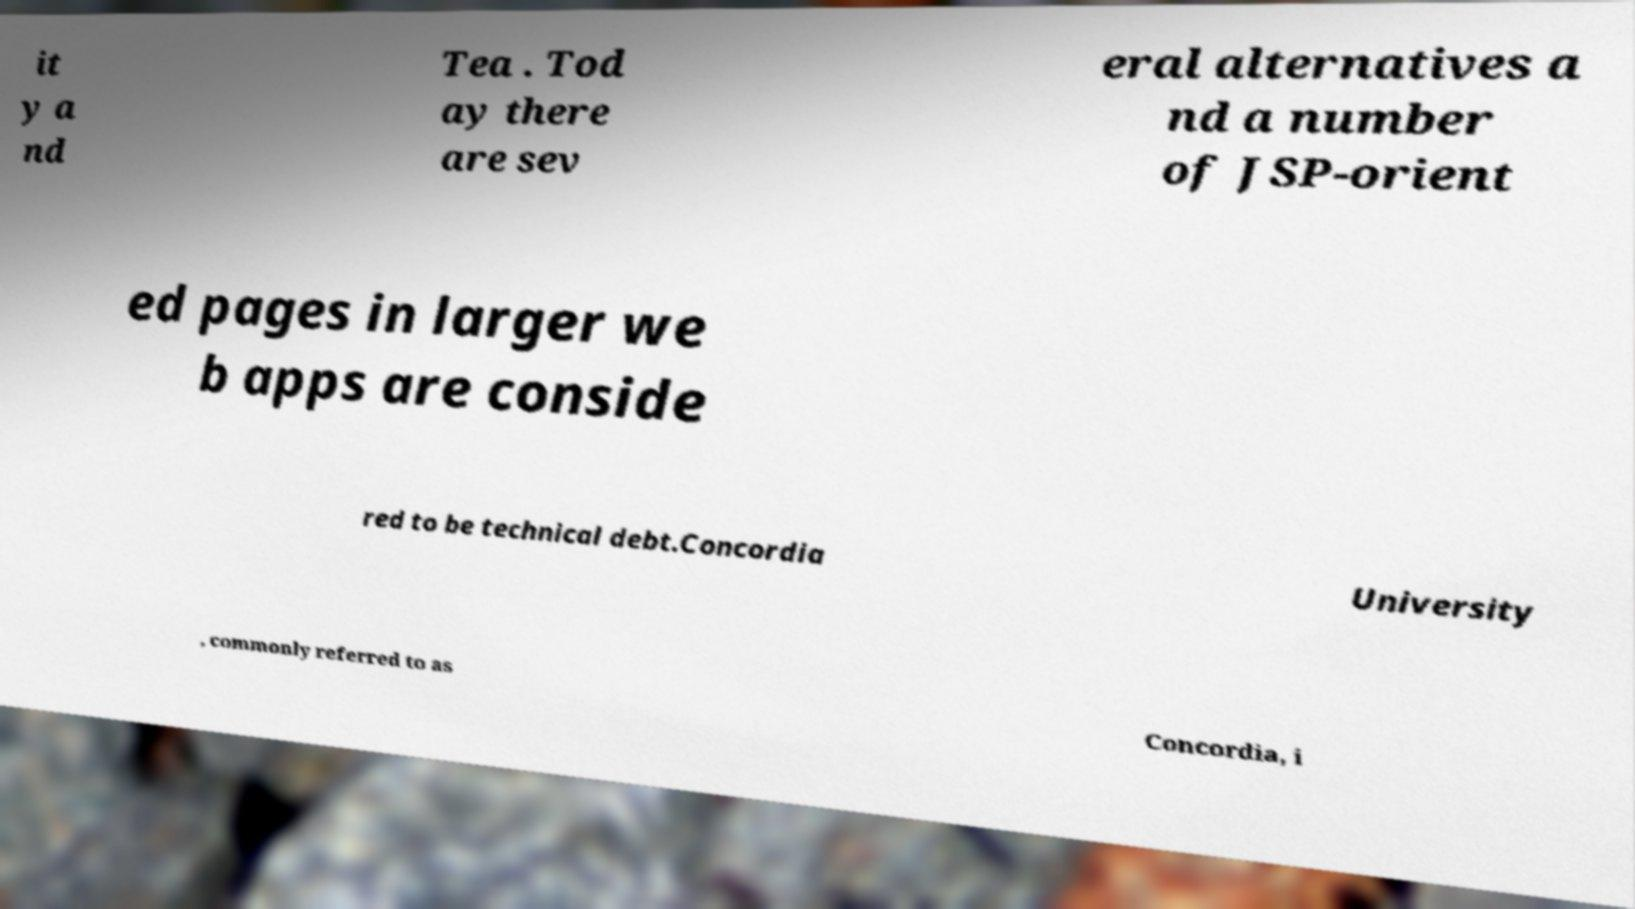Could you assist in decoding the text presented in this image and type it out clearly? it y a nd Tea . Tod ay there are sev eral alternatives a nd a number of JSP-orient ed pages in larger we b apps are conside red to be technical debt.Concordia University , commonly referred to as Concordia, i 